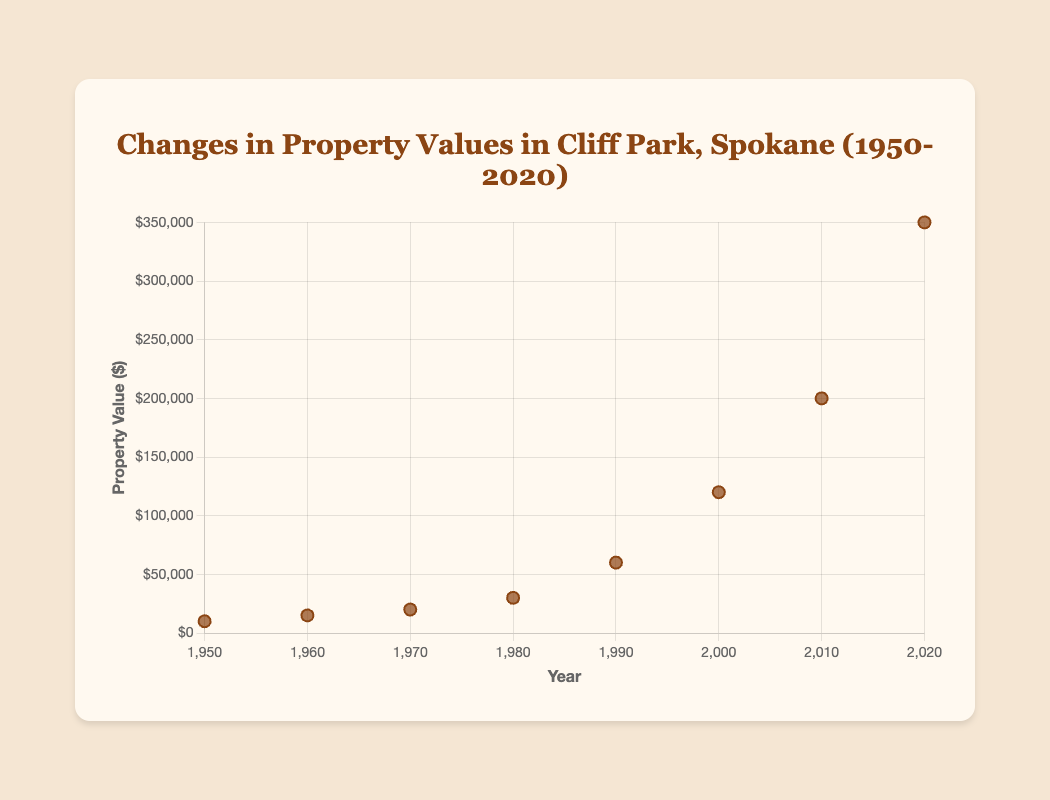What's the title of the scatter plot? The title is displayed at the top of the figure and typically provides a summary of the data depicted.
Answer: Changes in Property Values in Cliff Park, Spokane (1950-2020) How many years are included in the data? Count each unique year labeled along the x-axis or listed by each data point. There are 8 unique years: 1950, 1960, 1970, 1980, 1990, 2000, 2010, and 2020.
Answer: 8 What's the property value in 1970? Find the data point corresponding to the year 1970 on the x-axis and check its y-value.
Answer: $20000 What's the difference in property value between 1950 and 1960? Subtract the property value in 1950 from the property value in 1960 ($15000 - $10000).
Answer: $5000 How much did the property value increase from 1990 to 2000? Subtract the property value in 1990 from the property value in 2000 ($120000 - $60000).
Answer: $60000 Which year saw the largest increase in property value compared to the previous decade? Compare the differences in property values between consecutive decades: 1960-1950 ($5000), 1970-1960 ($5000), 1980-1970 ($10000), 1990-1980 ($30000), 2000-1990 ($60000), 2010-2000 ($80000), 2020-2010 ($150000). The largest increase is between 2010 and 2020.
Answer: 2020 What was the average property value in the decades from 1950 to 1980? Sum the property values for the years 1950, 1960, 1970, and 1980, then divide by 4. ($10000 + $15000 + $20000 + $30000) / 4 = $18750
Answer: $18750 Which decade had the smallest increase in property value? Compare the differences in property values between each decade: 1960-1950 ($5000), 1970-1960 ($5000), 1980-1970 ($10000), 1990-1980 ($30000), 2000-1990 ($60000), 2010-2000 ($80000), 2020-2010 ($150000). The smallest increase is between 1950 and 1960.
Answer: 1960 